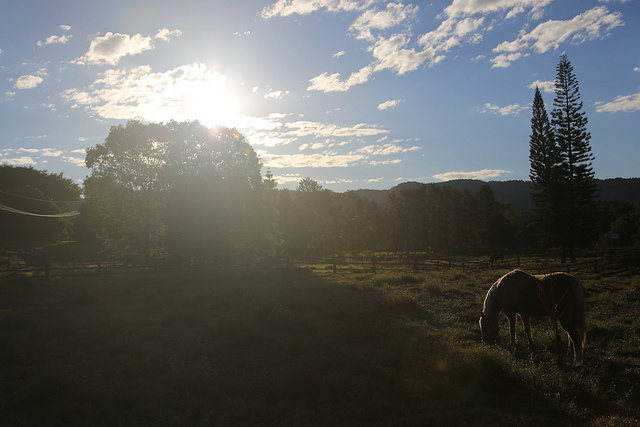What time of day does this scene appear to be? The scene appears to be in the early morning, as suggested by the low position of the bright sun and the soft golden light spreading across the landscape. 